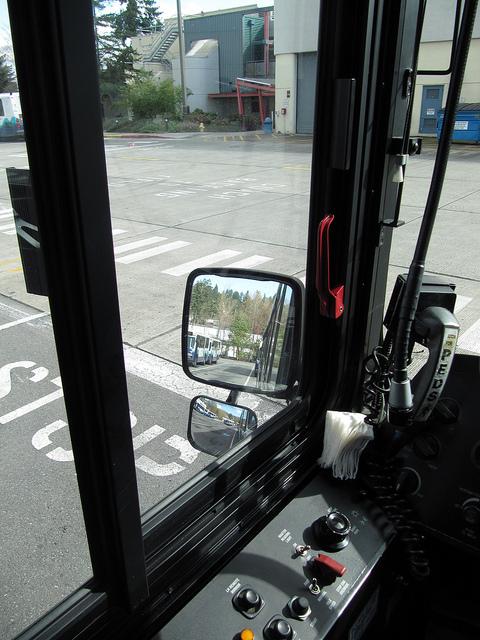What is the bus driver wearing?
Be succinct. Uniform. What is the purpose of some of the controls shown?
Quick response, please. Control vehicle. How is the bus driver feeling?
Be succinct. Tired. 